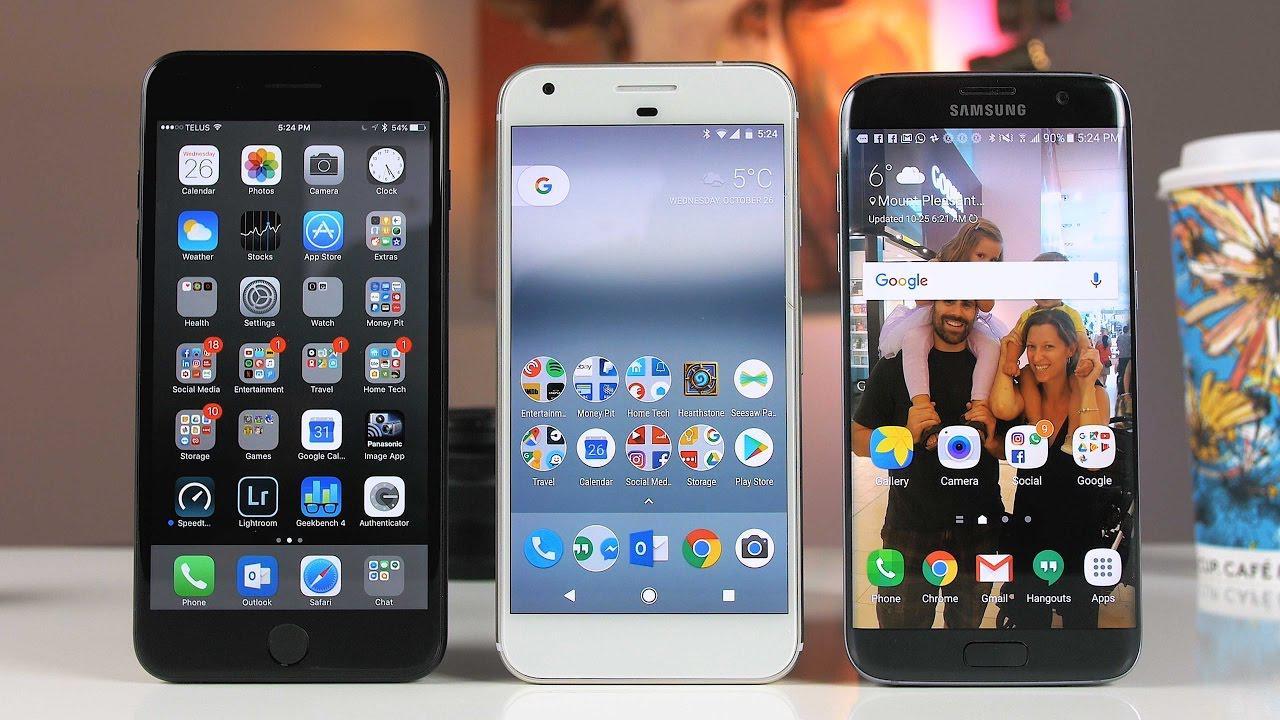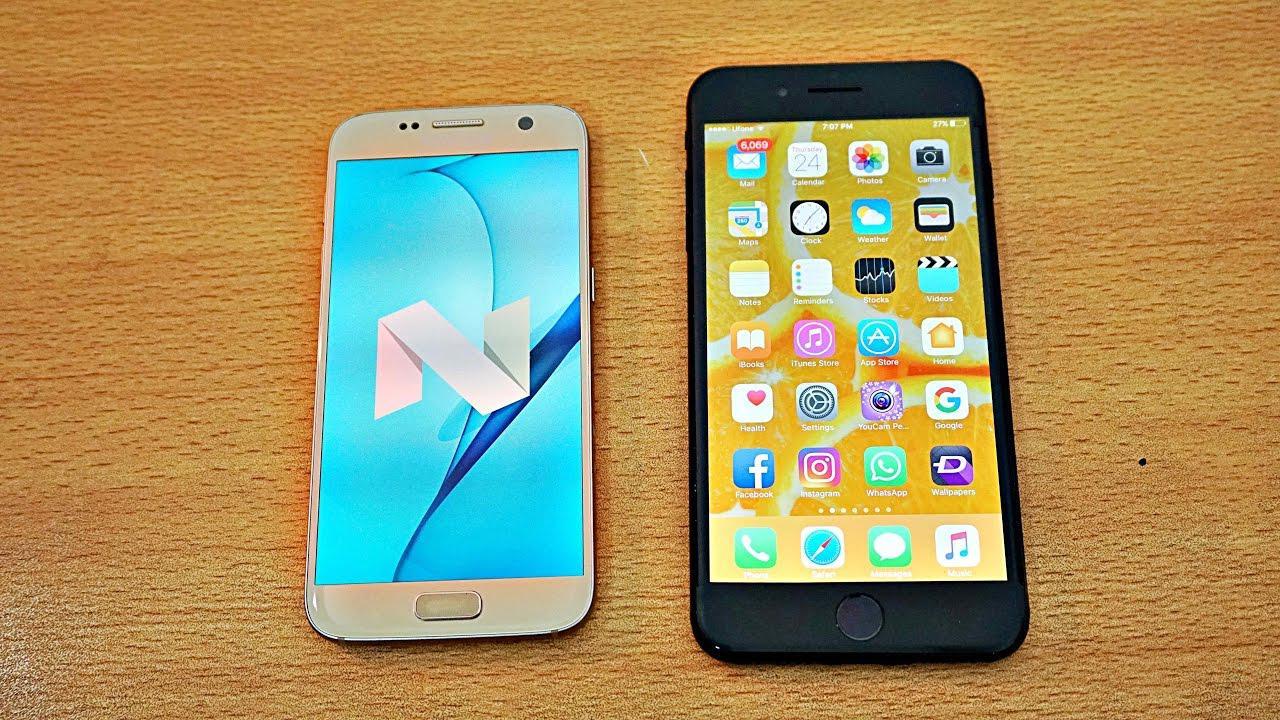The first image is the image on the left, the second image is the image on the right. Evaluate the accuracy of this statement regarding the images: "There are more phones in the image on the left.". Is it true? Answer yes or no. Yes. 